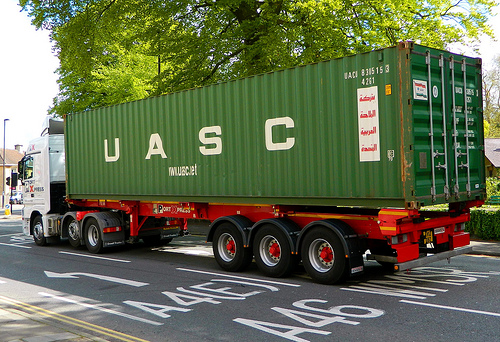Is this a desk or a bed? This piece of furniture is a bed. 